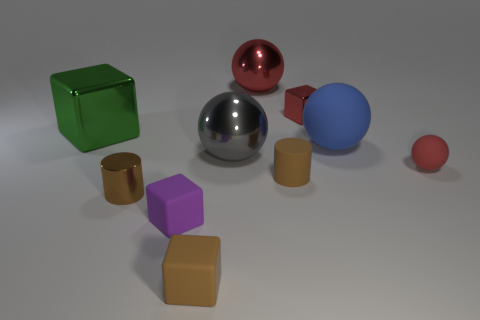There is a small brown matte object on the right side of the big gray metallic sphere; are there any tiny brown matte things that are behind it?
Provide a short and direct response. No. There is a tiny rubber object that is the same shape as the big gray metallic object; what is its color?
Offer a very short reply. Red. There is a cylinder that is to the left of the large red thing; is it the same color as the matte cylinder?
Provide a succinct answer. Yes. How many objects are large shiny balls in front of the small shiny cube or metallic objects?
Make the answer very short. 5. The tiny block behind the tiny metallic object that is in front of the ball on the right side of the large blue rubber thing is made of what material?
Keep it short and to the point. Metal. Are there more small brown rubber cubes that are behind the small shiny cylinder than matte spheres that are to the left of the red cube?
Offer a terse response. No. How many blocks are either large brown shiny things or small red rubber things?
Give a very brief answer. 0. There is a tiny brown rubber thing behind the tiny shiny thing to the left of the purple matte thing; how many tiny red metal things are right of it?
Provide a succinct answer. 1. What is the material of the large sphere that is the same color as the small rubber ball?
Make the answer very short. Metal. Is the number of brown matte spheres greater than the number of cubes?
Offer a very short reply. No. 